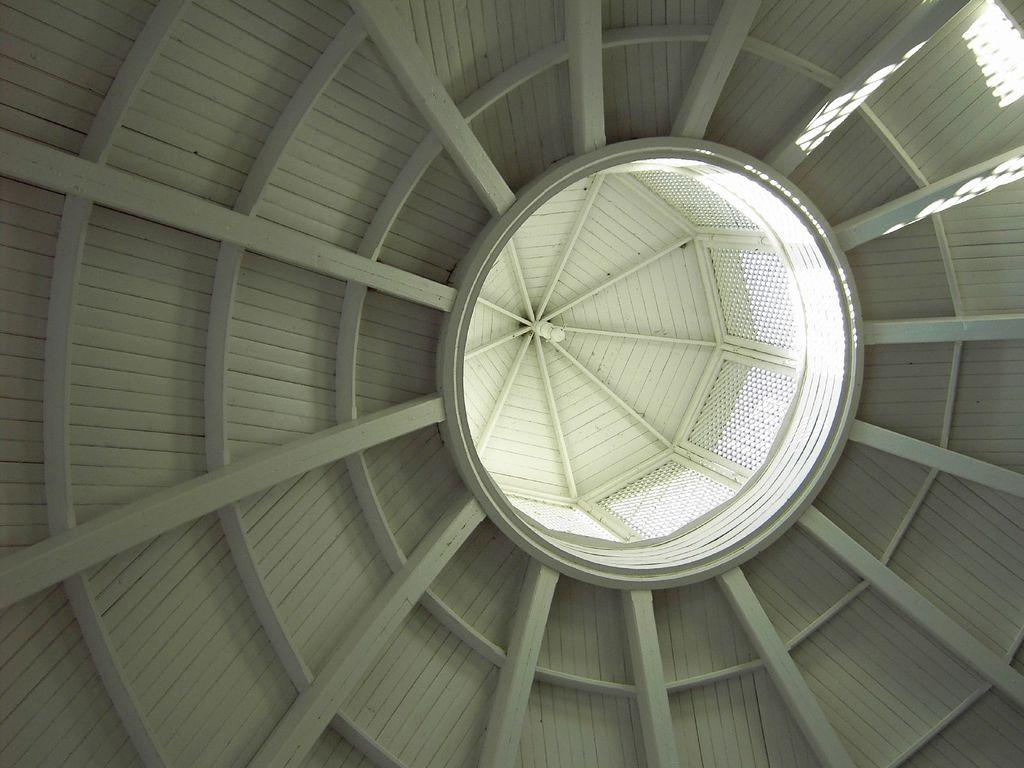What is the main structure visible in the image? There is a roof in the image. What type of steel is used to construct the spade in the image? There is no spade or steel present in the image; it only features a roof. 